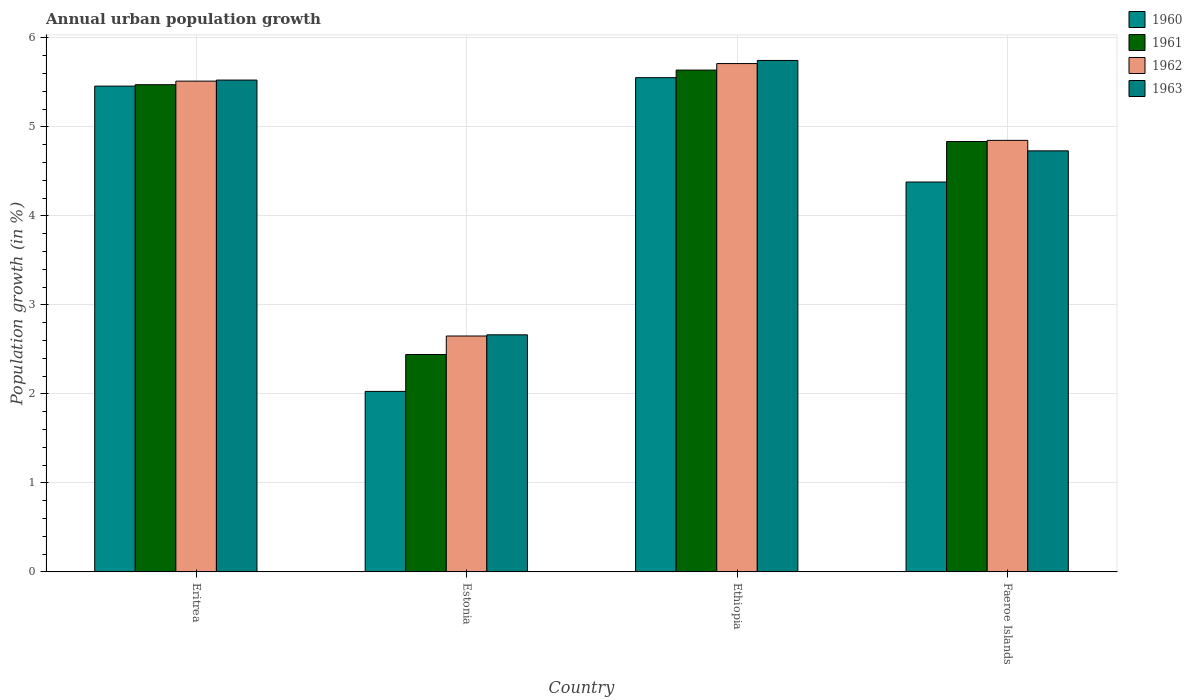How many different coloured bars are there?
Provide a succinct answer. 4. How many groups of bars are there?
Give a very brief answer. 4. Are the number of bars per tick equal to the number of legend labels?
Your response must be concise. Yes. What is the label of the 1st group of bars from the left?
Make the answer very short. Eritrea. What is the percentage of urban population growth in 1963 in Ethiopia?
Your response must be concise. 5.75. Across all countries, what is the maximum percentage of urban population growth in 1961?
Your response must be concise. 5.64. Across all countries, what is the minimum percentage of urban population growth in 1963?
Your answer should be very brief. 2.66. In which country was the percentage of urban population growth in 1962 maximum?
Your answer should be compact. Ethiopia. In which country was the percentage of urban population growth in 1963 minimum?
Make the answer very short. Estonia. What is the total percentage of urban population growth in 1960 in the graph?
Your answer should be very brief. 17.42. What is the difference between the percentage of urban population growth in 1961 in Estonia and that in Faeroe Islands?
Your answer should be compact. -2.39. What is the difference between the percentage of urban population growth in 1963 in Faeroe Islands and the percentage of urban population growth in 1961 in Eritrea?
Provide a short and direct response. -0.74. What is the average percentage of urban population growth in 1962 per country?
Offer a terse response. 4.68. What is the difference between the percentage of urban population growth of/in 1963 and percentage of urban population growth of/in 1961 in Eritrea?
Keep it short and to the point. 0.05. In how many countries, is the percentage of urban population growth in 1963 greater than 0.2 %?
Keep it short and to the point. 4. What is the ratio of the percentage of urban population growth in 1961 in Eritrea to that in Ethiopia?
Your answer should be compact. 0.97. Is the percentage of urban population growth in 1960 in Eritrea less than that in Ethiopia?
Keep it short and to the point. Yes. What is the difference between the highest and the second highest percentage of urban population growth in 1962?
Make the answer very short. 0.67. What is the difference between the highest and the lowest percentage of urban population growth in 1961?
Your answer should be very brief. 3.2. In how many countries, is the percentage of urban population growth in 1963 greater than the average percentage of urban population growth in 1963 taken over all countries?
Provide a short and direct response. 3. Is the sum of the percentage of urban population growth in 1960 in Eritrea and Ethiopia greater than the maximum percentage of urban population growth in 1963 across all countries?
Ensure brevity in your answer.  Yes. Is it the case that in every country, the sum of the percentage of urban population growth in 1962 and percentage of urban population growth in 1960 is greater than the sum of percentage of urban population growth in 1961 and percentage of urban population growth in 1963?
Offer a very short reply. No. What does the 2nd bar from the left in Ethiopia represents?
Provide a succinct answer. 1961. What is the difference between two consecutive major ticks on the Y-axis?
Keep it short and to the point. 1. Where does the legend appear in the graph?
Give a very brief answer. Top right. How many legend labels are there?
Your response must be concise. 4. What is the title of the graph?
Offer a very short reply. Annual urban population growth. What is the label or title of the Y-axis?
Offer a terse response. Population growth (in %). What is the Population growth (in %) in 1960 in Eritrea?
Ensure brevity in your answer.  5.46. What is the Population growth (in %) of 1961 in Eritrea?
Provide a short and direct response. 5.47. What is the Population growth (in %) in 1962 in Eritrea?
Make the answer very short. 5.51. What is the Population growth (in %) of 1963 in Eritrea?
Provide a succinct answer. 5.53. What is the Population growth (in %) of 1960 in Estonia?
Your response must be concise. 2.03. What is the Population growth (in %) of 1961 in Estonia?
Your answer should be compact. 2.44. What is the Population growth (in %) in 1962 in Estonia?
Offer a very short reply. 2.65. What is the Population growth (in %) of 1963 in Estonia?
Make the answer very short. 2.66. What is the Population growth (in %) in 1960 in Ethiopia?
Give a very brief answer. 5.55. What is the Population growth (in %) of 1961 in Ethiopia?
Give a very brief answer. 5.64. What is the Population growth (in %) in 1962 in Ethiopia?
Provide a short and direct response. 5.71. What is the Population growth (in %) of 1963 in Ethiopia?
Offer a very short reply. 5.75. What is the Population growth (in %) in 1960 in Faeroe Islands?
Make the answer very short. 4.38. What is the Population growth (in %) in 1961 in Faeroe Islands?
Provide a short and direct response. 4.84. What is the Population growth (in %) in 1962 in Faeroe Islands?
Your response must be concise. 4.85. What is the Population growth (in %) in 1963 in Faeroe Islands?
Your answer should be very brief. 4.73. Across all countries, what is the maximum Population growth (in %) in 1960?
Provide a short and direct response. 5.55. Across all countries, what is the maximum Population growth (in %) in 1961?
Your answer should be compact. 5.64. Across all countries, what is the maximum Population growth (in %) of 1962?
Ensure brevity in your answer.  5.71. Across all countries, what is the maximum Population growth (in %) of 1963?
Your response must be concise. 5.75. Across all countries, what is the minimum Population growth (in %) of 1960?
Make the answer very short. 2.03. Across all countries, what is the minimum Population growth (in %) in 1961?
Ensure brevity in your answer.  2.44. Across all countries, what is the minimum Population growth (in %) of 1962?
Provide a short and direct response. 2.65. Across all countries, what is the minimum Population growth (in %) in 1963?
Ensure brevity in your answer.  2.66. What is the total Population growth (in %) of 1960 in the graph?
Offer a very short reply. 17.42. What is the total Population growth (in %) of 1961 in the graph?
Give a very brief answer. 18.39. What is the total Population growth (in %) in 1962 in the graph?
Offer a very short reply. 18.72. What is the total Population growth (in %) of 1963 in the graph?
Ensure brevity in your answer.  18.66. What is the difference between the Population growth (in %) of 1960 in Eritrea and that in Estonia?
Your answer should be very brief. 3.43. What is the difference between the Population growth (in %) in 1961 in Eritrea and that in Estonia?
Give a very brief answer. 3.03. What is the difference between the Population growth (in %) in 1962 in Eritrea and that in Estonia?
Make the answer very short. 2.86. What is the difference between the Population growth (in %) in 1963 in Eritrea and that in Estonia?
Your answer should be very brief. 2.86. What is the difference between the Population growth (in %) in 1960 in Eritrea and that in Ethiopia?
Ensure brevity in your answer.  -0.1. What is the difference between the Population growth (in %) of 1961 in Eritrea and that in Ethiopia?
Your response must be concise. -0.16. What is the difference between the Population growth (in %) of 1962 in Eritrea and that in Ethiopia?
Your answer should be very brief. -0.2. What is the difference between the Population growth (in %) in 1963 in Eritrea and that in Ethiopia?
Offer a terse response. -0.22. What is the difference between the Population growth (in %) in 1960 in Eritrea and that in Faeroe Islands?
Your response must be concise. 1.08. What is the difference between the Population growth (in %) of 1961 in Eritrea and that in Faeroe Islands?
Ensure brevity in your answer.  0.64. What is the difference between the Population growth (in %) of 1962 in Eritrea and that in Faeroe Islands?
Your answer should be very brief. 0.67. What is the difference between the Population growth (in %) in 1963 in Eritrea and that in Faeroe Islands?
Make the answer very short. 0.8. What is the difference between the Population growth (in %) of 1960 in Estonia and that in Ethiopia?
Your answer should be very brief. -3.52. What is the difference between the Population growth (in %) of 1961 in Estonia and that in Ethiopia?
Provide a succinct answer. -3.19. What is the difference between the Population growth (in %) in 1962 in Estonia and that in Ethiopia?
Offer a terse response. -3.06. What is the difference between the Population growth (in %) of 1963 in Estonia and that in Ethiopia?
Ensure brevity in your answer.  -3.08. What is the difference between the Population growth (in %) of 1960 in Estonia and that in Faeroe Islands?
Your response must be concise. -2.35. What is the difference between the Population growth (in %) in 1961 in Estonia and that in Faeroe Islands?
Give a very brief answer. -2.39. What is the difference between the Population growth (in %) of 1962 in Estonia and that in Faeroe Islands?
Offer a very short reply. -2.2. What is the difference between the Population growth (in %) in 1963 in Estonia and that in Faeroe Islands?
Keep it short and to the point. -2.07. What is the difference between the Population growth (in %) in 1960 in Ethiopia and that in Faeroe Islands?
Give a very brief answer. 1.17. What is the difference between the Population growth (in %) of 1961 in Ethiopia and that in Faeroe Islands?
Your answer should be compact. 0.8. What is the difference between the Population growth (in %) in 1962 in Ethiopia and that in Faeroe Islands?
Offer a terse response. 0.86. What is the difference between the Population growth (in %) of 1963 in Ethiopia and that in Faeroe Islands?
Your answer should be very brief. 1.02. What is the difference between the Population growth (in %) in 1960 in Eritrea and the Population growth (in %) in 1961 in Estonia?
Provide a short and direct response. 3.01. What is the difference between the Population growth (in %) of 1960 in Eritrea and the Population growth (in %) of 1962 in Estonia?
Your answer should be very brief. 2.81. What is the difference between the Population growth (in %) in 1960 in Eritrea and the Population growth (in %) in 1963 in Estonia?
Give a very brief answer. 2.79. What is the difference between the Population growth (in %) of 1961 in Eritrea and the Population growth (in %) of 1962 in Estonia?
Your answer should be compact. 2.82. What is the difference between the Population growth (in %) of 1961 in Eritrea and the Population growth (in %) of 1963 in Estonia?
Offer a terse response. 2.81. What is the difference between the Population growth (in %) in 1962 in Eritrea and the Population growth (in %) in 1963 in Estonia?
Your answer should be compact. 2.85. What is the difference between the Population growth (in %) in 1960 in Eritrea and the Population growth (in %) in 1961 in Ethiopia?
Provide a succinct answer. -0.18. What is the difference between the Population growth (in %) in 1960 in Eritrea and the Population growth (in %) in 1962 in Ethiopia?
Give a very brief answer. -0.25. What is the difference between the Population growth (in %) of 1960 in Eritrea and the Population growth (in %) of 1963 in Ethiopia?
Offer a terse response. -0.29. What is the difference between the Population growth (in %) in 1961 in Eritrea and the Population growth (in %) in 1962 in Ethiopia?
Ensure brevity in your answer.  -0.24. What is the difference between the Population growth (in %) of 1961 in Eritrea and the Population growth (in %) of 1963 in Ethiopia?
Keep it short and to the point. -0.27. What is the difference between the Population growth (in %) of 1962 in Eritrea and the Population growth (in %) of 1963 in Ethiopia?
Give a very brief answer. -0.23. What is the difference between the Population growth (in %) of 1960 in Eritrea and the Population growth (in %) of 1961 in Faeroe Islands?
Ensure brevity in your answer.  0.62. What is the difference between the Population growth (in %) in 1960 in Eritrea and the Population growth (in %) in 1962 in Faeroe Islands?
Your answer should be very brief. 0.61. What is the difference between the Population growth (in %) in 1960 in Eritrea and the Population growth (in %) in 1963 in Faeroe Islands?
Offer a very short reply. 0.73. What is the difference between the Population growth (in %) in 1961 in Eritrea and the Population growth (in %) in 1962 in Faeroe Islands?
Ensure brevity in your answer.  0.63. What is the difference between the Population growth (in %) of 1961 in Eritrea and the Population growth (in %) of 1963 in Faeroe Islands?
Ensure brevity in your answer.  0.74. What is the difference between the Population growth (in %) in 1962 in Eritrea and the Population growth (in %) in 1963 in Faeroe Islands?
Give a very brief answer. 0.78. What is the difference between the Population growth (in %) in 1960 in Estonia and the Population growth (in %) in 1961 in Ethiopia?
Your response must be concise. -3.61. What is the difference between the Population growth (in %) of 1960 in Estonia and the Population growth (in %) of 1962 in Ethiopia?
Offer a very short reply. -3.68. What is the difference between the Population growth (in %) of 1960 in Estonia and the Population growth (in %) of 1963 in Ethiopia?
Provide a succinct answer. -3.72. What is the difference between the Population growth (in %) of 1961 in Estonia and the Population growth (in %) of 1962 in Ethiopia?
Offer a terse response. -3.27. What is the difference between the Population growth (in %) of 1961 in Estonia and the Population growth (in %) of 1963 in Ethiopia?
Your answer should be very brief. -3.3. What is the difference between the Population growth (in %) of 1962 in Estonia and the Population growth (in %) of 1963 in Ethiopia?
Make the answer very short. -3.1. What is the difference between the Population growth (in %) of 1960 in Estonia and the Population growth (in %) of 1961 in Faeroe Islands?
Your response must be concise. -2.81. What is the difference between the Population growth (in %) in 1960 in Estonia and the Population growth (in %) in 1962 in Faeroe Islands?
Your response must be concise. -2.82. What is the difference between the Population growth (in %) of 1960 in Estonia and the Population growth (in %) of 1963 in Faeroe Islands?
Offer a very short reply. -2.7. What is the difference between the Population growth (in %) of 1961 in Estonia and the Population growth (in %) of 1962 in Faeroe Islands?
Your response must be concise. -2.41. What is the difference between the Population growth (in %) in 1961 in Estonia and the Population growth (in %) in 1963 in Faeroe Islands?
Provide a short and direct response. -2.29. What is the difference between the Population growth (in %) in 1962 in Estonia and the Population growth (in %) in 1963 in Faeroe Islands?
Ensure brevity in your answer.  -2.08. What is the difference between the Population growth (in %) of 1960 in Ethiopia and the Population growth (in %) of 1961 in Faeroe Islands?
Your answer should be compact. 0.72. What is the difference between the Population growth (in %) in 1960 in Ethiopia and the Population growth (in %) in 1962 in Faeroe Islands?
Ensure brevity in your answer.  0.7. What is the difference between the Population growth (in %) in 1960 in Ethiopia and the Population growth (in %) in 1963 in Faeroe Islands?
Make the answer very short. 0.82. What is the difference between the Population growth (in %) of 1961 in Ethiopia and the Population growth (in %) of 1962 in Faeroe Islands?
Your answer should be compact. 0.79. What is the difference between the Population growth (in %) of 1961 in Ethiopia and the Population growth (in %) of 1963 in Faeroe Islands?
Offer a very short reply. 0.91. What is the difference between the Population growth (in %) of 1962 in Ethiopia and the Population growth (in %) of 1963 in Faeroe Islands?
Offer a terse response. 0.98. What is the average Population growth (in %) of 1960 per country?
Offer a very short reply. 4.35. What is the average Population growth (in %) in 1961 per country?
Provide a short and direct response. 4.6. What is the average Population growth (in %) in 1962 per country?
Ensure brevity in your answer.  4.68. What is the average Population growth (in %) of 1963 per country?
Your answer should be compact. 4.67. What is the difference between the Population growth (in %) of 1960 and Population growth (in %) of 1961 in Eritrea?
Offer a very short reply. -0.02. What is the difference between the Population growth (in %) of 1960 and Population growth (in %) of 1962 in Eritrea?
Provide a short and direct response. -0.06. What is the difference between the Population growth (in %) of 1960 and Population growth (in %) of 1963 in Eritrea?
Provide a succinct answer. -0.07. What is the difference between the Population growth (in %) of 1961 and Population growth (in %) of 1962 in Eritrea?
Ensure brevity in your answer.  -0.04. What is the difference between the Population growth (in %) of 1961 and Population growth (in %) of 1963 in Eritrea?
Keep it short and to the point. -0.05. What is the difference between the Population growth (in %) in 1962 and Population growth (in %) in 1963 in Eritrea?
Provide a short and direct response. -0.01. What is the difference between the Population growth (in %) of 1960 and Population growth (in %) of 1961 in Estonia?
Provide a short and direct response. -0.41. What is the difference between the Population growth (in %) in 1960 and Population growth (in %) in 1962 in Estonia?
Provide a succinct answer. -0.62. What is the difference between the Population growth (in %) in 1960 and Population growth (in %) in 1963 in Estonia?
Your answer should be compact. -0.64. What is the difference between the Population growth (in %) of 1961 and Population growth (in %) of 1962 in Estonia?
Offer a very short reply. -0.21. What is the difference between the Population growth (in %) of 1961 and Population growth (in %) of 1963 in Estonia?
Ensure brevity in your answer.  -0.22. What is the difference between the Population growth (in %) of 1962 and Population growth (in %) of 1963 in Estonia?
Provide a short and direct response. -0.01. What is the difference between the Population growth (in %) in 1960 and Population growth (in %) in 1961 in Ethiopia?
Offer a very short reply. -0.09. What is the difference between the Population growth (in %) of 1960 and Population growth (in %) of 1962 in Ethiopia?
Your answer should be compact. -0.16. What is the difference between the Population growth (in %) in 1960 and Population growth (in %) in 1963 in Ethiopia?
Provide a succinct answer. -0.19. What is the difference between the Population growth (in %) in 1961 and Population growth (in %) in 1962 in Ethiopia?
Your answer should be compact. -0.07. What is the difference between the Population growth (in %) in 1961 and Population growth (in %) in 1963 in Ethiopia?
Your answer should be very brief. -0.11. What is the difference between the Population growth (in %) in 1962 and Population growth (in %) in 1963 in Ethiopia?
Make the answer very short. -0.04. What is the difference between the Population growth (in %) in 1960 and Population growth (in %) in 1961 in Faeroe Islands?
Offer a terse response. -0.46. What is the difference between the Population growth (in %) in 1960 and Population growth (in %) in 1962 in Faeroe Islands?
Your answer should be very brief. -0.47. What is the difference between the Population growth (in %) of 1960 and Population growth (in %) of 1963 in Faeroe Islands?
Offer a terse response. -0.35. What is the difference between the Population growth (in %) of 1961 and Population growth (in %) of 1962 in Faeroe Islands?
Your answer should be very brief. -0.01. What is the difference between the Population growth (in %) in 1961 and Population growth (in %) in 1963 in Faeroe Islands?
Provide a succinct answer. 0.11. What is the difference between the Population growth (in %) of 1962 and Population growth (in %) of 1963 in Faeroe Islands?
Offer a terse response. 0.12. What is the ratio of the Population growth (in %) of 1960 in Eritrea to that in Estonia?
Provide a short and direct response. 2.69. What is the ratio of the Population growth (in %) in 1961 in Eritrea to that in Estonia?
Offer a very short reply. 2.24. What is the ratio of the Population growth (in %) in 1962 in Eritrea to that in Estonia?
Provide a succinct answer. 2.08. What is the ratio of the Population growth (in %) in 1963 in Eritrea to that in Estonia?
Your answer should be compact. 2.07. What is the ratio of the Population growth (in %) of 1960 in Eritrea to that in Ethiopia?
Offer a very short reply. 0.98. What is the ratio of the Population growth (in %) in 1961 in Eritrea to that in Ethiopia?
Your answer should be compact. 0.97. What is the ratio of the Population growth (in %) in 1962 in Eritrea to that in Ethiopia?
Give a very brief answer. 0.97. What is the ratio of the Population growth (in %) of 1963 in Eritrea to that in Ethiopia?
Keep it short and to the point. 0.96. What is the ratio of the Population growth (in %) in 1960 in Eritrea to that in Faeroe Islands?
Make the answer very short. 1.25. What is the ratio of the Population growth (in %) of 1961 in Eritrea to that in Faeroe Islands?
Provide a short and direct response. 1.13. What is the ratio of the Population growth (in %) of 1962 in Eritrea to that in Faeroe Islands?
Offer a very short reply. 1.14. What is the ratio of the Population growth (in %) in 1963 in Eritrea to that in Faeroe Islands?
Provide a short and direct response. 1.17. What is the ratio of the Population growth (in %) in 1960 in Estonia to that in Ethiopia?
Your answer should be very brief. 0.37. What is the ratio of the Population growth (in %) in 1961 in Estonia to that in Ethiopia?
Keep it short and to the point. 0.43. What is the ratio of the Population growth (in %) in 1962 in Estonia to that in Ethiopia?
Keep it short and to the point. 0.46. What is the ratio of the Population growth (in %) of 1963 in Estonia to that in Ethiopia?
Offer a very short reply. 0.46. What is the ratio of the Population growth (in %) of 1960 in Estonia to that in Faeroe Islands?
Offer a very short reply. 0.46. What is the ratio of the Population growth (in %) of 1961 in Estonia to that in Faeroe Islands?
Provide a short and direct response. 0.51. What is the ratio of the Population growth (in %) of 1962 in Estonia to that in Faeroe Islands?
Give a very brief answer. 0.55. What is the ratio of the Population growth (in %) of 1963 in Estonia to that in Faeroe Islands?
Your answer should be compact. 0.56. What is the ratio of the Population growth (in %) of 1960 in Ethiopia to that in Faeroe Islands?
Offer a very short reply. 1.27. What is the ratio of the Population growth (in %) of 1961 in Ethiopia to that in Faeroe Islands?
Provide a succinct answer. 1.17. What is the ratio of the Population growth (in %) of 1962 in Ethiopia to that in Faeroe Islands?
Provide a succinct answer. 1.18. What is the ratio of the Population growth (in %) in 1963 in Ethiopia to that in Faeroe Islands?
Give a very brief answer. 1.21. What is the difference between the highest and the second highest Population growth (in %) of 1960?
Provide a short and direct response. 0.1. What is the difference between the highest and the second highest Population growth (in %) in 1961?
Offer a terse response. 0.16. What is the difference between the highest and the second highest Population growth (in %) of 1962?
Your response must be concise. 0.2. What is the difference between the highest and the second highest Population growth (in %) of 1963?
Make the answer very short. 0.22. What is the difference between the highest and the lowest Population growth (in %) in 1960?
Ensure brevity in your answer.  3.52. What is the difference between the highest and the lowest Population growth (in %) in 1961?
Provide a succinct answer. 3.19. What is the difference between the highest and the lowest Population growth (in %) of 1962?
Keep it short and to the point. 3.06. What is the difference between the highest and the lowest Population growth (in %) of 1963?
Provide a short and direct response. 3.08. 